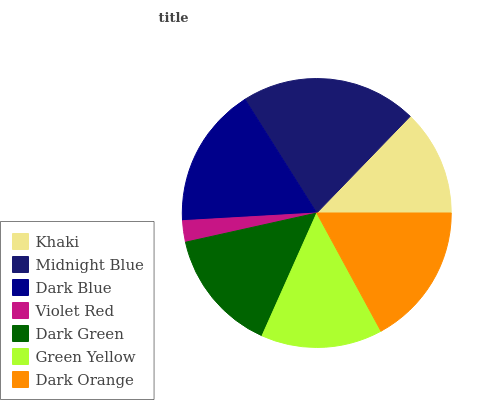Is Violet Red the minimum?
Answer yes or no. Yes. Is Midnight Blue the maximum?
Answer yes or no. Yes. Is Dark Blue the minimum?
Answer yes or no. No. Is Dark Blue the maximum?
Answer yes or no. No. Is Midnight Blue greater than Dark Blue?
Answer yes or no. Yes. Is Dark Blue less than Midnight Blue?
Answer yes or no. Yes. Is Dark Blue greater than Midnight Blue?
Answer yes or no. No. Is Midnight Blue less than Dark Blue?
Answer yes or no. No. Is Dark Green the high median?
Answer yes or no. Yes. Is Dark Green the low median?
Answer yes or no. Yes. Is Green Yellow the high median?
Answer yes or no. No. Is Khaki the low median?
Answer yes or no. No. 